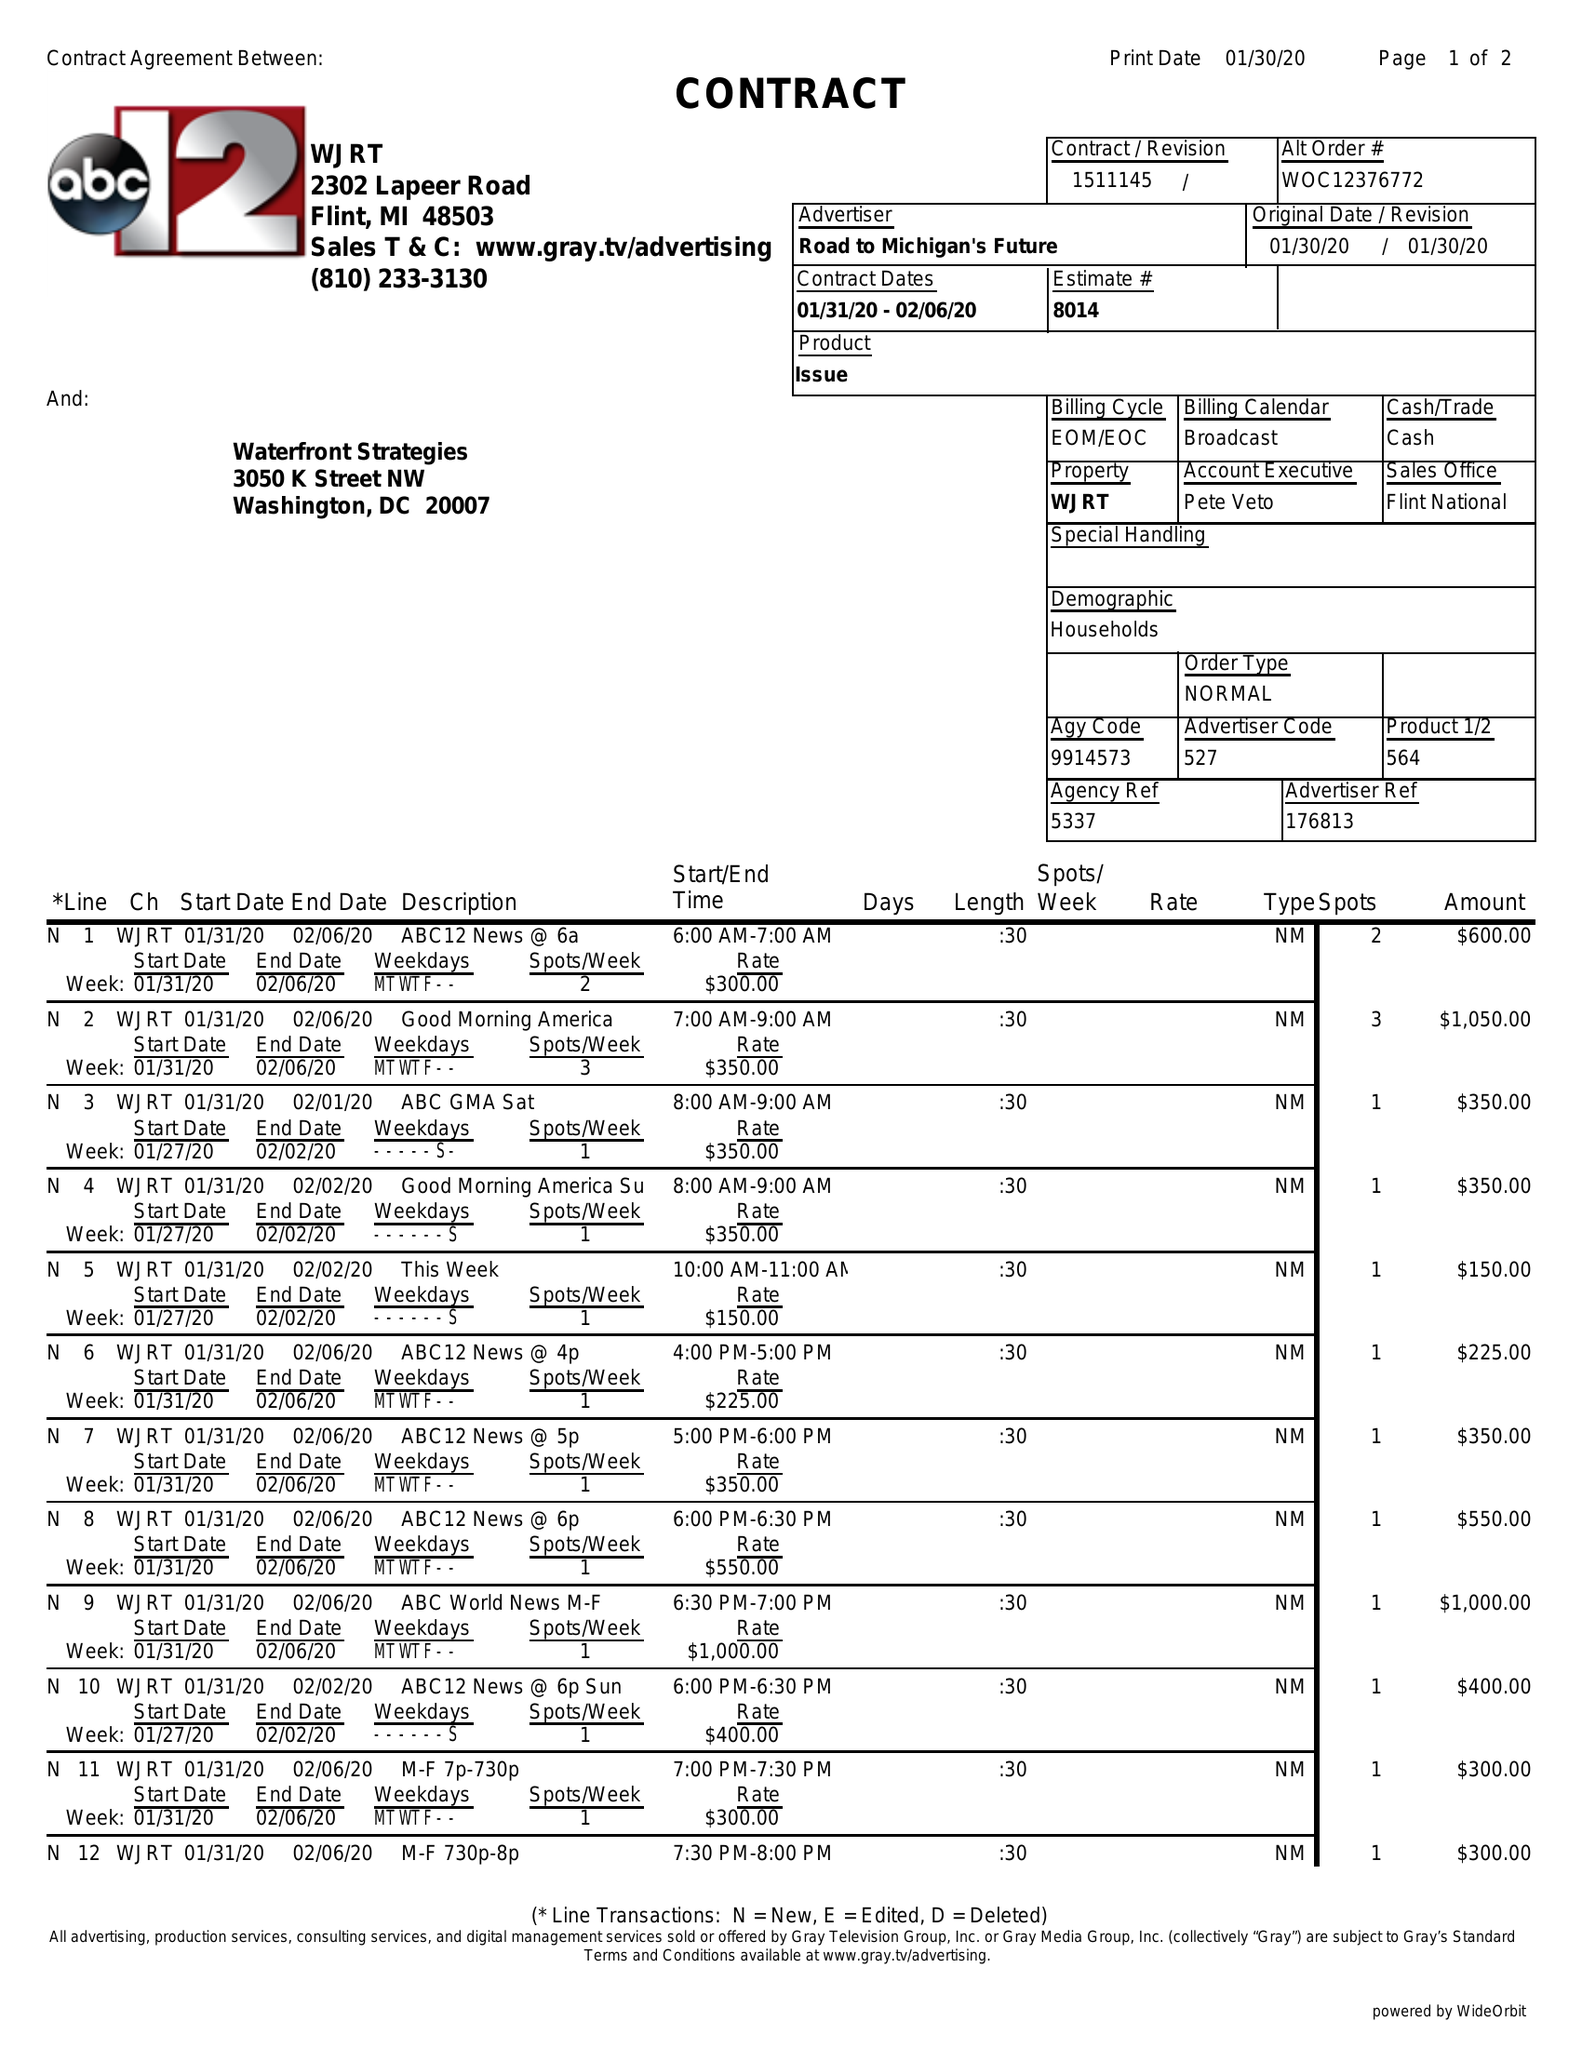What is the value for the flight_to?
Answer the question using a single word or phrase. 02/06/20 